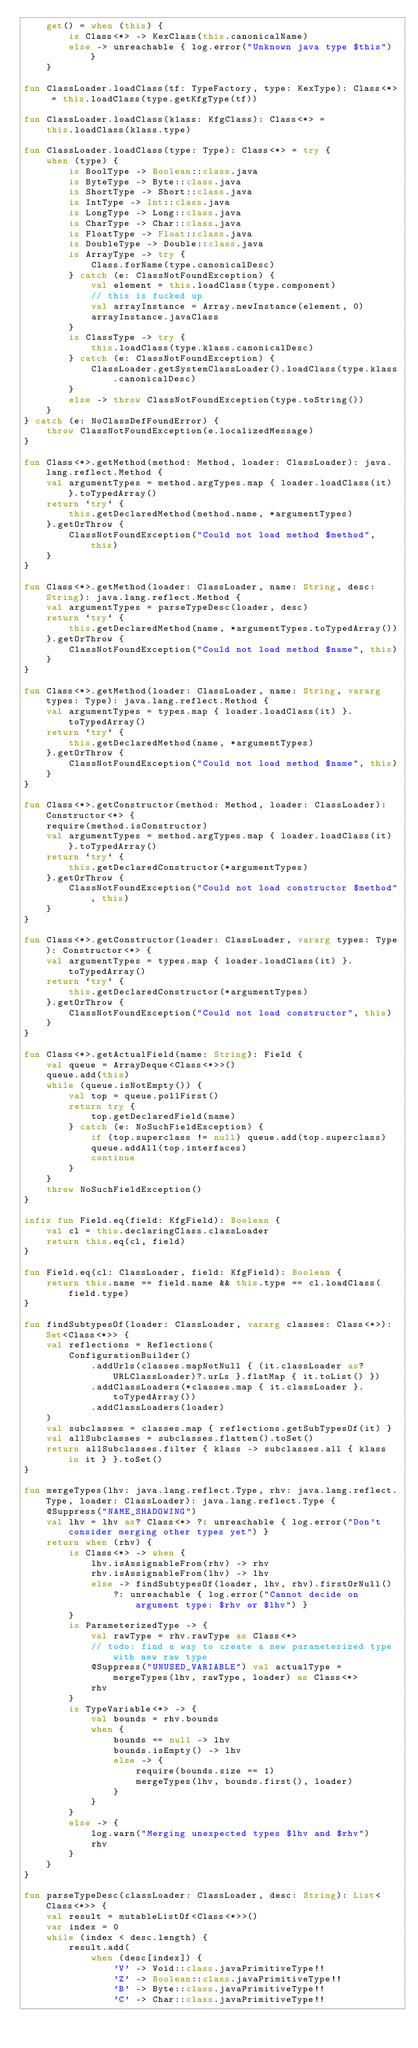Convert code to text. <code><loc_0><loc_0><loc_500><loc_500><_Kotlin_>    get() = when (this) {
        is Class<*> -> KexClass(this.canonicalName)
        else -> unreachable { log.error("Unknown java type $this") }
    }

fun ClassLoader.loadClass(tf: TypeFactory, type: KexType): Class<*> = this.loadClass(type.getKfgType(tf))

fun ClassLoader.loadClass(klass: KfgClass): Class<*> =
    this.loadClass(klass.type)

fun ClassLoader.loadClass(type: Type): Class<*> = try {
    when (type) {
        is BoolType -> Boolean::class.java
        is ByteType -> Byte::class.java
        is ShortType -> Short::class.java
        is IntType -> Int::class.java
        is LongType -> Long::class.java
        is CharType -> Char::class.java
        is FloatType -> Float::class.java
        is DoubleType -> Double::class.java
        is ArrayType -> try {
            Class.forName(type.canonicalDesc)
        } catch (e: ClassNotFoundException) {
            val element = this.loadClass(type.component)
            // this is fucked up
            val arrayInstance = Array.newInstance(element, 0)
            arrayInstance.javaClass
        }
        is ClassType -> try {
            this.loadClass(type.klass.canonicalDesc)
        } catch (e: ClassNotFoundException) {
            ClassLoader.getSystemClassLoader().loadClass(type.klass.canonicalDesc)
        }
        else -> throw ClassNotFoundException(type.toString())
    }
} catch (e: NoClassDefFoundError) {
    throw ClassNotFoundException(e.localizedMessage)
}

fun Class<*>.getMethod(method: Method, loader: ClassLoader): java.lang.reflect.Method {
    val argumentTypes = method.argTypes.map { loader.loadClass(it) }.toTypedArray()
    return `try` {
        this.getDeclaredMethod(method.name, *argumentTypes)
    }.getOrThrow {
        ClassNotFoundException("Could not load method $method", this)
    }
}

fun Class<*>.getMethod(loader: ClassLoader, name: String, desc: String): java.lang.reflect.Method {
    val argumentTypes = parseTypeDesc(loader, desc)
    return `try` {
        this.getDeclaredMethod(name, *argumentTypes.toTypedArray())
    }.getOrThrow {
        ClassNotFoundException("Could not load method $name", this)
    }
}

fun Class<*>.getMethod(loader: ClassLoader, name: String, vararg types: Type): java.lang.reflect.Method {
    val argumentTypes = types.map { loader.loadClass(it) }.toTypedArray()
    return `try` {
        this.getDeclaredMethod(name, *argumentTypes)
    }.getOrThrow {
        ClassNotFoundException("Could not load method $name", this)
    }
}

fun Class<*>.getConstructor(method: Method, loader: ClassLoader): Constructor<*> {
    require(method.isConstructor)
    val argumentTypes = method.argTypes.map { loader.loadClass(it) }.toTypedArray()
    return `try` {
        this.getDeclaredConstructor(*argumentTypes)
    }.getOrThrow {
        ClassNotFoundException("Could not load constructor $method", this)
    }
}

fun Class<*>.getConstructor(loader: ClassLoader, vararg types: Type): Constructor<*> {
    val argumentTypes = types.map { loader.loadClass(it) }.toTypedArray()
    return `try` {
        this.getDeclaredConstructor(*argumentTypes)
    }.getOrThrow {
        ClassNotFoundException("Could not load constructor", this)
    }
}

fun Class<*>.getActualField(name: String): Field {
    val queue = ArrayDeque<Class<*>>()
    queue.add(this)
    while (queue.isNotEmpty()) {
        val top = queue.pollFirst()
        return try {
            top.getDeclaredField(name)
        } catch (e: NoSuchFieldException) {
            if (top.superclass != null) queue.add(top.superclass)
            queue.addAll(top.interfaces)
            continue
        }
    }
    throw NoSuchFieldException()
}

infix fun Field.eq(field: KfgField): Boolean {
    val cl = this.declaringClass.classLoader
    return this.eq(cl, field)
}

fun Field.eq(cl: ClassLoader, field: KfgField): Boolean {
    return this.name == field.name && this.type == cl.loadClass(field.type)
}

fun findSubtypesOf(loader: ClassLoader, vararg classes: Class<*>): Set<Class<*>> {
    val reflections = Reflections(
        ConfigurationBuilder()
            .addUrls(classes.mapNotNull { (it.classLoader as? URLClassLoader)?.urLs }.flatMap { it.toList() })
            .addClassLoaders(*classes.map { it.classLoader }.toTypedArray())
            .addClassLoaders(loader)
    )
    val subclasses = classes.map { reflections.getSubTypesOf(it) }
    val allSubclasses = subclasses.flatten().toSet()
    return allSubclasses.filter { klass -> subclasses.all { klass in it } }.toSet()
}

fun mergeTypes(lhv: java.lang.reflect.Type, rhv: java.lang.reflect.Type, loader: ClassLoader): java.lang.reflect.Type {
    @Suppress("NAME_SHADOWING")
    val lhv = lhv as? Class<*> ?: unreachable { log.error("Don't consider merging other types yet") }
    return when (rhv) {
        is Class<*> -> when {
            lhv.isAssignableFrom(rhv) -> rhv
            rhv.isAssignableFrom(lhv) -> lhv
            else -> findSubtypesOf(loader, lhv, rhv).firstOrNull()
                ?: unreachable { log.error("Cannot decide on argument type: $rhv or $lhv") }
        }
        is ParameterizedType -> {
            val rawType = rhv.rawType as Class<*>
            // todo: find a way to create a new parameterized type with new raw type
            @Suppress("UNUSED_VARIABLE") val actualType = mergeTypes(lhv, rawType, loader) as Class<*>
            rhv
        }
        is TypeVariable<*> -> {
            val bounds = rhv.bounds
            when {
                bounds == null -> lhv
                bounds.isEmpty() -> lhv
                else -> {
                    require(bounds.size == 1)
                    mergeTypes(lhv, bounds.first(), loader)
                }
            }
        }
        else -> {
            log.warn("Merging unexpected types $lhv and $rhv")
            rhv
        }
    }
}

fun parseTypeDesc(classLoader: ClassLoader, desc: String): List<Class<*>> {
    val result = mutableListOf<Class<*>>()
    var index = 0
    while (index < desc.length) {
        result.add(
            when (desc[index]) {
                'V' -> Void::class.javaPrimitiveType!!
                'Z' -> Boolean::class.javaPrimitiveType!!
                'B' -> Byte::class.javaPrimitiveType!!
                'C' -> Char::class.javaPrimitiveType!!</code> 